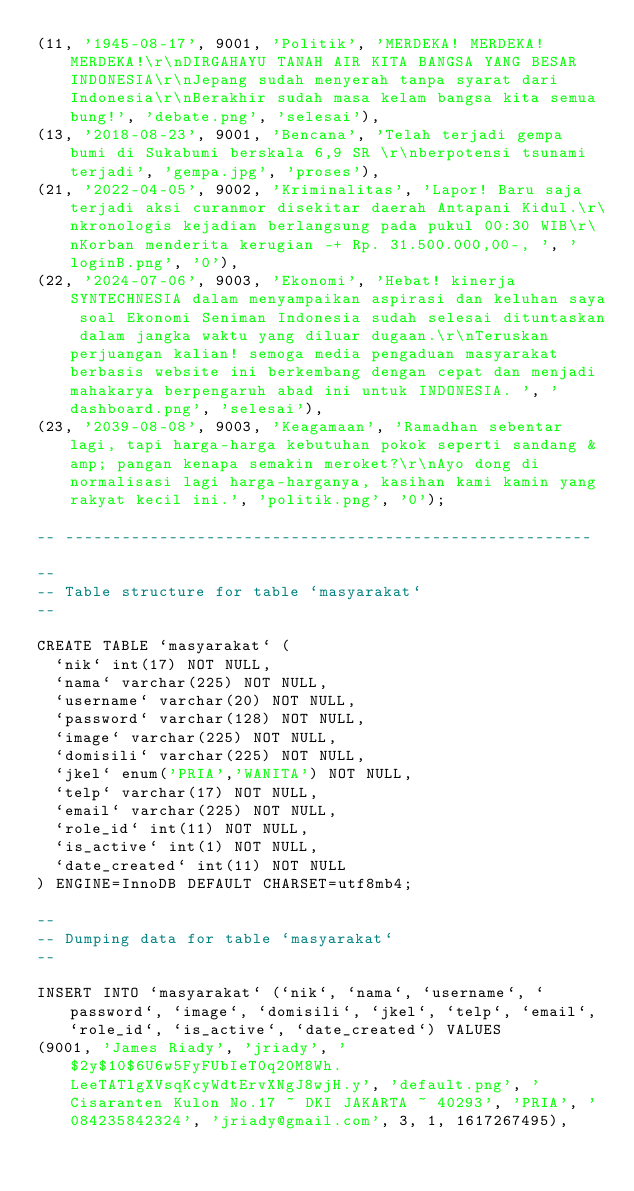<code> <loc_0><loc_0><loc_500><loc_500><_SQL_>(11, '1945-08-17', 9001, 'Politik', 'MERDEKA! MERDEKA! MERDEKA!\r\nDIRGAHAYU TANAH AIR KITA BANGSA YANG BESAR INDONESIA\r\nJepang sudah menyerah tanpa syarat dari Indonesia\r\nBerakhir sudah masa kelam bangsa kita semua bung!', 'debate.png', 'selesai'),
(13, '2018-08-23', 9001, 'Bencana', 'Telah terjadi gempa bumi di Sukabumi berskala 6,9 SR \r\nberpotensi tsunami terjadi', 'gempa.jpg', 'proses'),
(21, '2022-04-05', 9002, 'Kriminalitas', 'Lapor! Baru saja terjadi aksi curanmor disekitar daerah Antapani Kidul.\r\nkronologis kejadian berlangsung pada pukul 00:30 WIB\r\nKorban menderita kerugian -+ Rp. 31.500.000,00-, ', 'loginB.png', '0'),
(22, '2024-07-06', 9003, 'Ekonomi', 'Hebat! kinerja SYNTECHNESIA dalam menyampaikan aspirasi dan keluhan saya soal Ekonomi Seniman Indonesia sudah selesai dituntaskan dalam jangka waktu yang diluar dugaan.\r\nTeruskan perjuangan kalian! semoga media pengaduan masyarakat berbasis website ini berkembang dengan cepat dan menjadi mahakarya berpengaruh abad ini untuk INDONESIA. ', 'dashboard.png', 'selesai'),
(23, '2039-08-08', 9003, 'Keagamaan', 'Ramadhan sebentar lagi, tapi harga-harga kebutuhan pokok seperti sandang &amp; pangan kenapa semakin meroket?\r\nAyo dong di normalisasi lagi harga-harganya, kasihan kami kamin yang rakyat kecil ini.', 'politik.png', '0');

-- --------------------------------------------------------

--
-- Table structure for table `masyarakat`
--

CREATE TABLE `masyarakat` (
  `nik` int(17) NOT NULL,
  `nama` varchar(225) NOT NULL,
  `username` varchar(20) NOT NULL,
  `password` varchar(128) NOT NULL,
  `image` varchar(225) NOT NULL,
  `domisili` varchar(225) NOT NULL,
  `jkel` enum('PRIA','WANITA') NOT NULL,
  `telp` varchar(17) NOT NULL,
  `email` varchar(225) NOT NULL,
  `role_id` int(11) NOT NULL,
  `is_active` int(1) NOT NULL,
  `date_created` int(11) NOT NULL
) ENGINE=InnoDB DEFAULT CHARSET=utf8mb4;

--
-- Dumping data for table `masyarakat`
--

INSERT INTO `masyarakat` (`nik`, `nama`, `username`, `password`, `image`, `domisili`, `jkel`, `telp`, `email`, `role_id`, `is_active`, `date_created`) VALUES
(9001, 'James Riady', 'jriady', '$2y$10$6U6w5FyFUbIeT0q20M8Wh.LeeTATlgXVsqKcyWdtErvXNgJ8wjH.y', 'default.png', 'Cisaranten Kulon No.17 ~ DKI JAKARTA ~ 40293', 'PRIA', '084235842324', 'jriady@gmail.com', 3, 1, 1617267495),</code> 